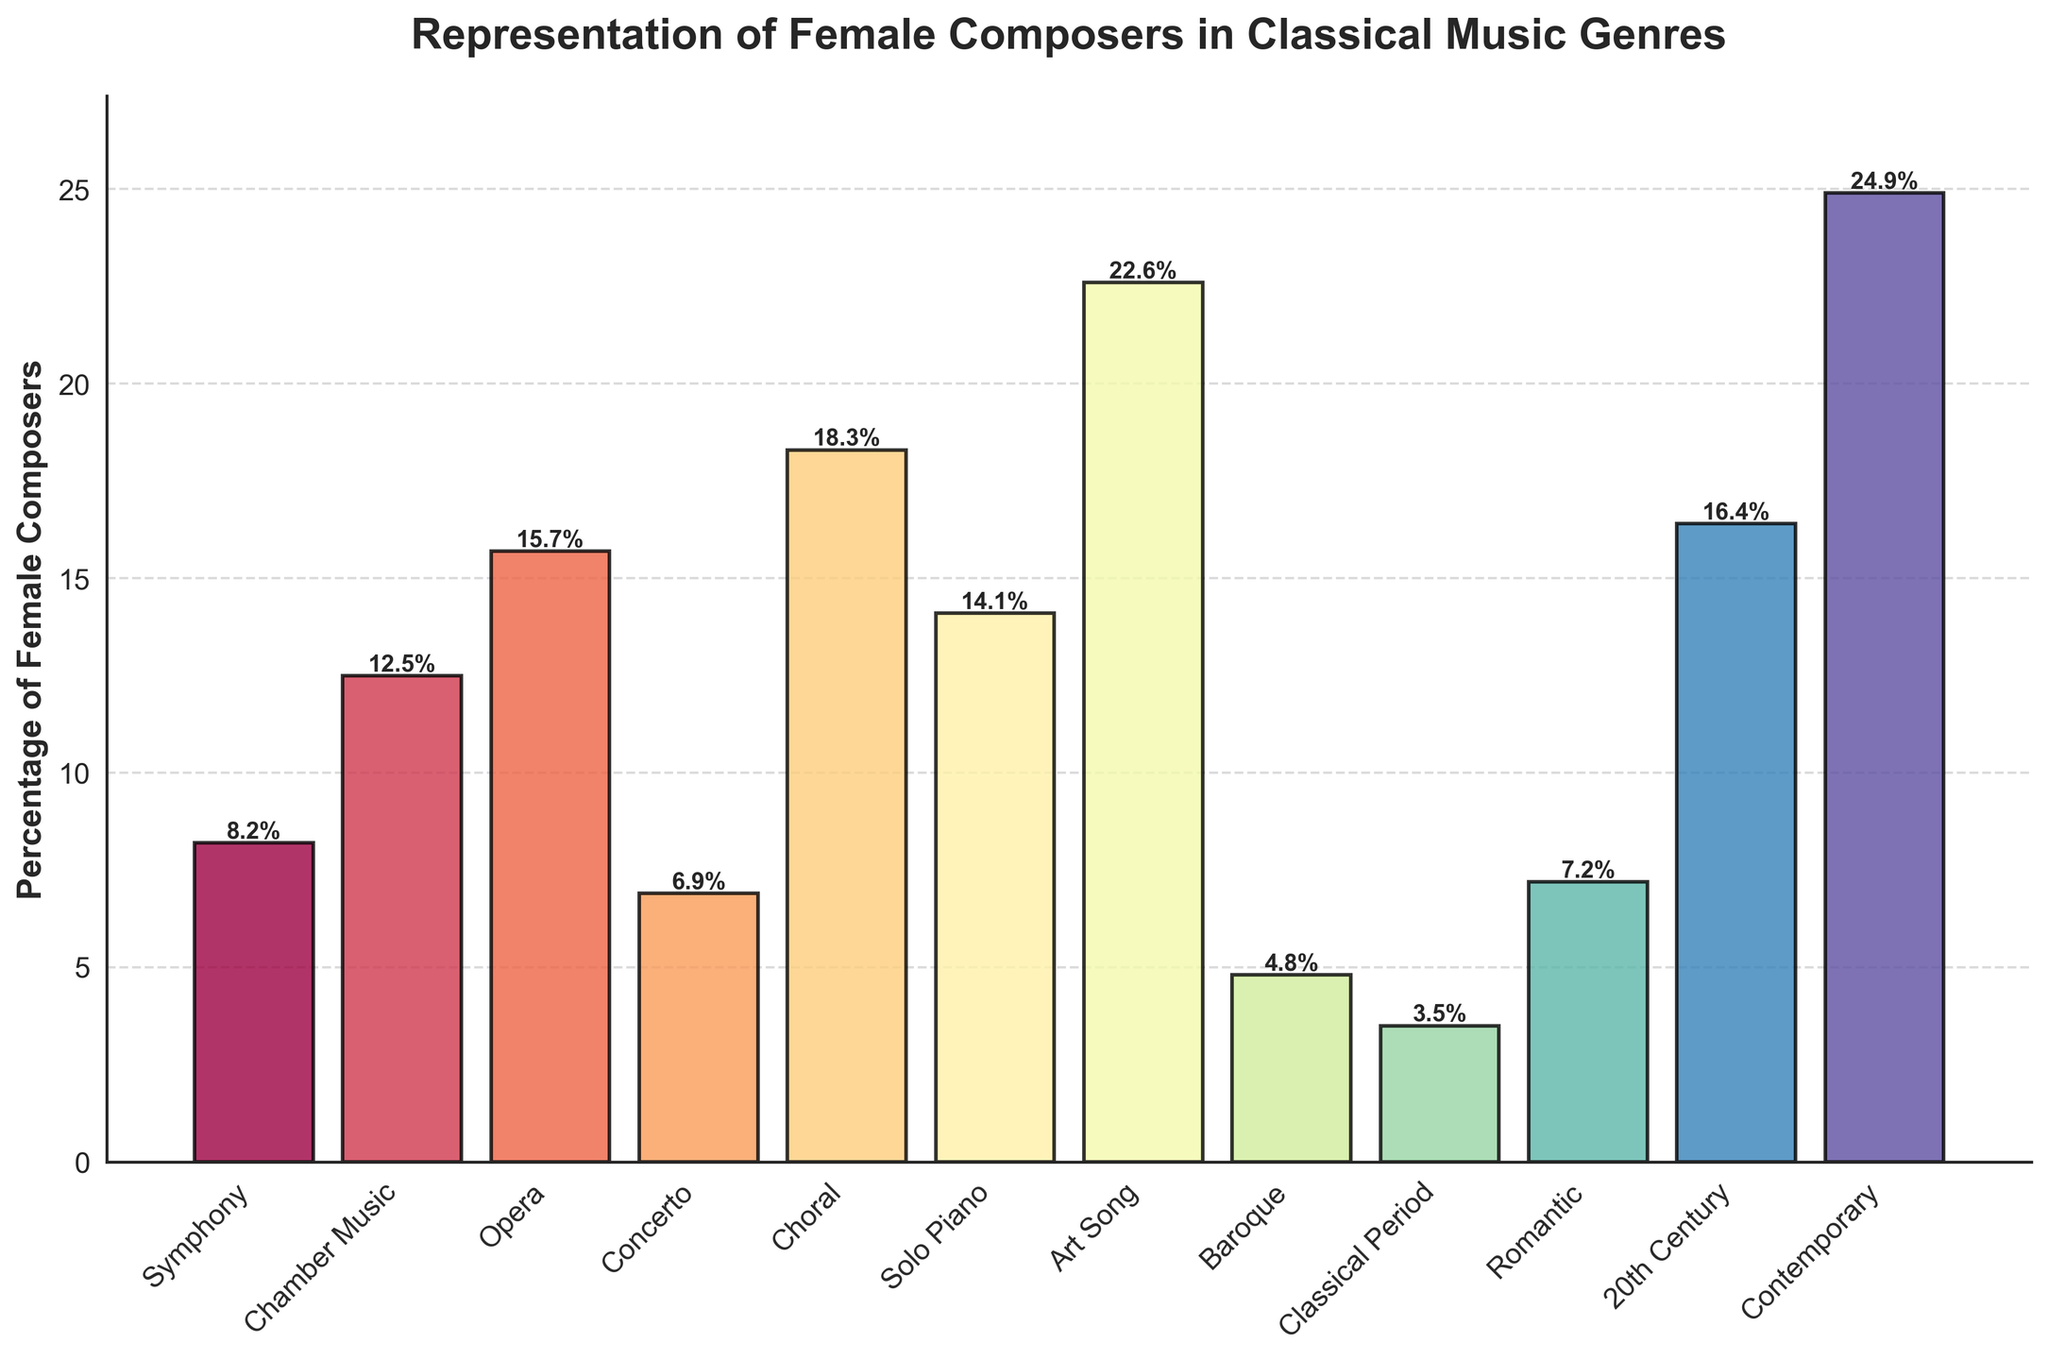What genre has the highest representation of female composers? By looking at the bar chart, we can observe which bar is the tallest. The "Contemporary" genre has the highest bar, indicating the highest percentage of female composers.
Answer: Contemporary Which genre has the lowest representation of female composers? By checking the shortest bar in the chart, it is evident that the "Classical Period" has the smallest bar, indicating the lowest percentage of female composers.
Answer: Classical Period What is the difference in the percentage of female composers between Opera and Choral genres? The percentage of female composers in Opera is 15.7%, and in Choral, it is 18.3%. The difference is calculated by subtracting the smaller value from the larger value: 18.3% - 15.7% = 2.6%.
Answer: 2.6% Compare the representation of female composers in Symphony and Romantic genres. The percentage of female composers in Symphony is 8.2%, and in Romantic, it is 7.2%. Comparing these values, Symphony has a slightly higher percentage than Romantic.
Answer: Symphony What is the total percentage of female composers in Symphony, Chamber Music, and Concerto genres combined? We sum the percentages for Symphony (8.2%), Chamber Music (12.5%), and Concerto (6.9%): 8.2% + 12.5% + 6.9% = 27.6%.
Answer: 27.6% Is the representation of female composers in Solo Piano higher than in Opera? The percentage of female composers in Solo Piano is 14.1% and in Opera, it is 15.7%. Comparing these values shows that Opera has a higher percentage than Solo Piano.
Answer: No How does the percentage of female composers in the Baroque genre compare to Contemporary? Baroque has a percentage of 4.8%, and Contemporary has 24.9%. Therefore, Contemporary has a much higher representation of female composers compared to Baroque.
Answer: Contemporary Identify the two genres with the closest percentages of female composers. By examining the bars, the percentages of female composers in Symphony (8.2%) and Romantic (7.2%) are closest, with a difference of only 1%.
Answer: Symphony and Romantic What is the average percentage of female composers in the Choral, Solo Piano, and Art Song genres? Calculating the average involves summing the percentages for Choral (18.3%), Solo Piano (14.1%), and Art Song (22.6%), then dividing by 3: (18.3% + 14.1% + 22.6%) / 3 = 55% / 3 ≈ 18.3%.
Answer: 18.3% Determine the range of percentages represented by the genres. The range is found by subtracting the smallest percentage (Classical Period at 3.5%) from the largest percentage (Contemporary at 24.9%): 24.9% - 3.5% = 21.4%.
Answer: 21.4% 